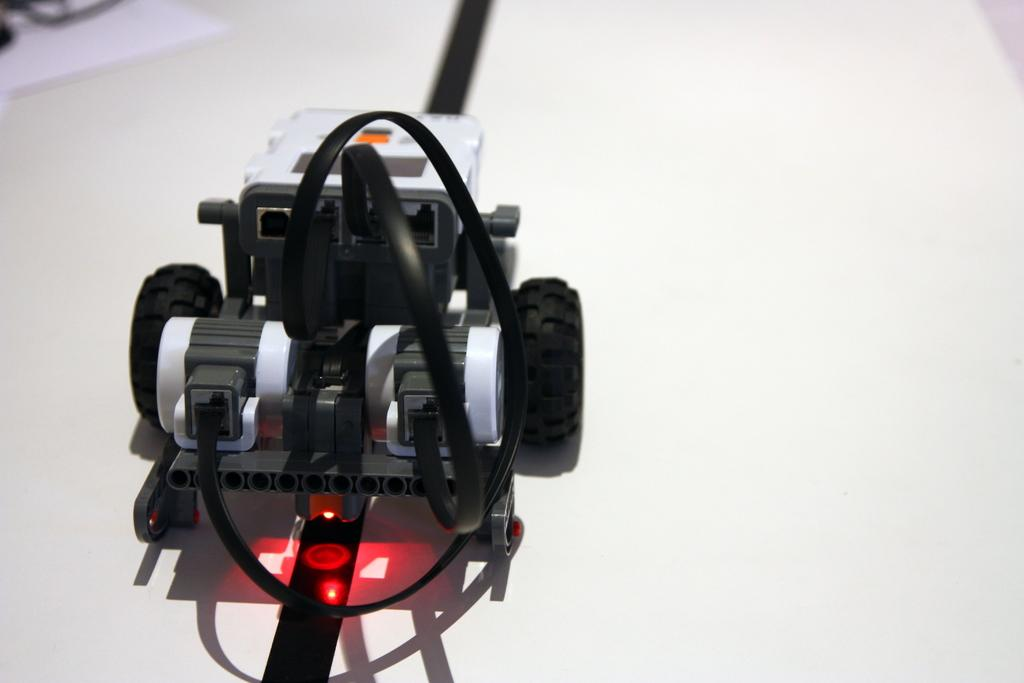What is the main object in the image? There is a toy car in the image. What colors are used for the toy car? The toy car is in black and white color. What is the color of the surface on which the toy car is placed? The toy car is on a white color surface. How many bags of popcorn are visible in the image? There are no bags of popcorn present in the image. What type of toys, besides the toy car, can be seen in the image? There are no other toys visible in the image; only the black and white toy car is present. 